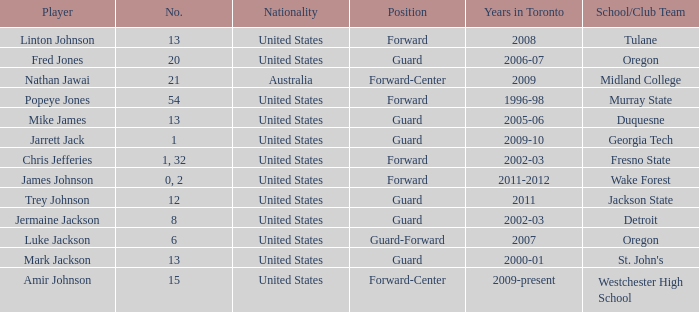What are the total number of positions on the Toronto team in 2006-07? 1.0. 